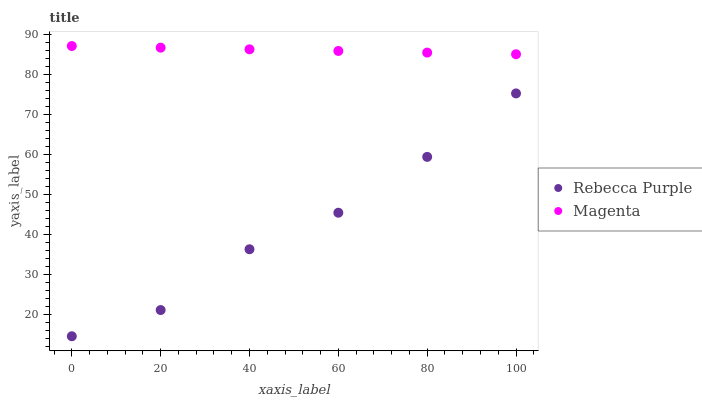Does Rebecca Purple have the minimum area under the curve?
Answer yes or no. Yes. Does Magenta have the maximum area under the curve?
Answer yes or no. Yes. Does Rebecca Purple have the maximum area under the curve?
Answer yes or no. No. Is Magenta the smoothest?
Answer yes or no. Yes. Is Rebecca Purple the roughest?
Answer yes or no. Yes. Is Rebecca Purple the smoothest?
Answer yes or no. No. Does Rebecca Purple have the lowest value?
Answer yes or no. Yes. Does Magenta have the highest value?
Answer yes or no. Yes. Does Rebecca Purple have the highest value?
Answer yes or no. No. Is Rebecca Purple less than Magenta?
Answer yes or no. Yes. Is Magenta greater than Rebecca Purple?
Answer yes or no. Yes. Does Rebecca Purple intersect Magenta?
Answer yes or no. No. 